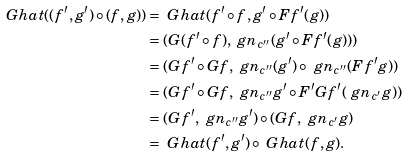Convert formula to latex. <formula><loc_0><loc_0><loc_500><loc_500>\ G h a t ( ( f ^ { \prime } , g ^ { \prime } ) \circ ( f , g ) ) & = \ G h a t ( f ^ { \prime } \circ f , g ^ { \prime } \circ F f ^ { \prime } ( g ) ) \\ & = ( G ( f ^ { \prime } \circ f ) , \ g n _ { c ^ { \prime \prime } } ( g ^ { \prime } \circ F f ^ { \prime } ( g ) ) ) \\ & = ( G f ^ { \prime } \circ G f , \ g n _ { c ^ { \prime \prime } } ( g ^ { \prime } ) \circ \ g n _ { c ^ { \prime \prime } } ( F f ^ { \prime } g ) ) \\ & = ( G f ^ { \prime } \circ G f , \ g n _ { c ^ { \prime \prime } } g ^ { \prime } \circ F ^ { \prime } G f ^ { \prime } ( \ g n _ { c ^ { \prime } } g ) ) \\ & = ( G f ^ { \prime } , \ g n _ { c ^ { \prime \prime } } g ^ { \prime } ) \circ ( G f , \ g n _ { c ^ { \prime } } g ) \\ & = \ G h a t ( f ^ { \prime } , g ^ { \prime } ) \circ \ G h a t ( f , g ) .</formula> 